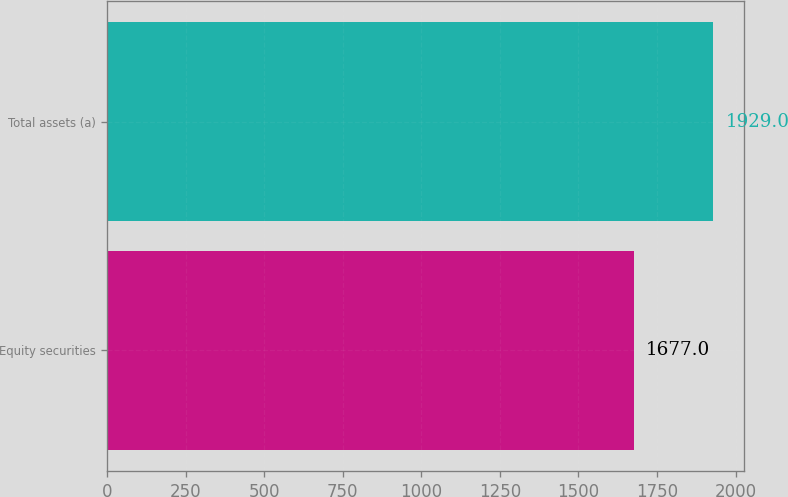<chart> <loc_0><loc_0><loc_500><loc_500><bar_chart><fcel>Equity securities<fcel>Total assets (a)<nl><fcel>1677<fcel>1929<nl></chart> 